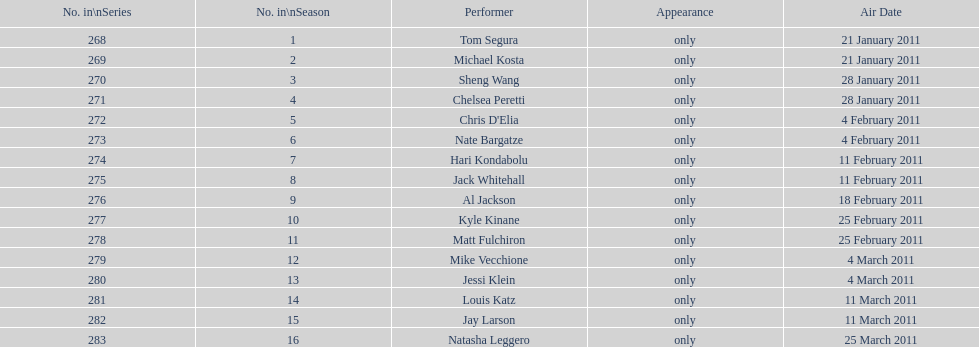Who is the last performer mentioned on this chart? Natasha Leggero. 